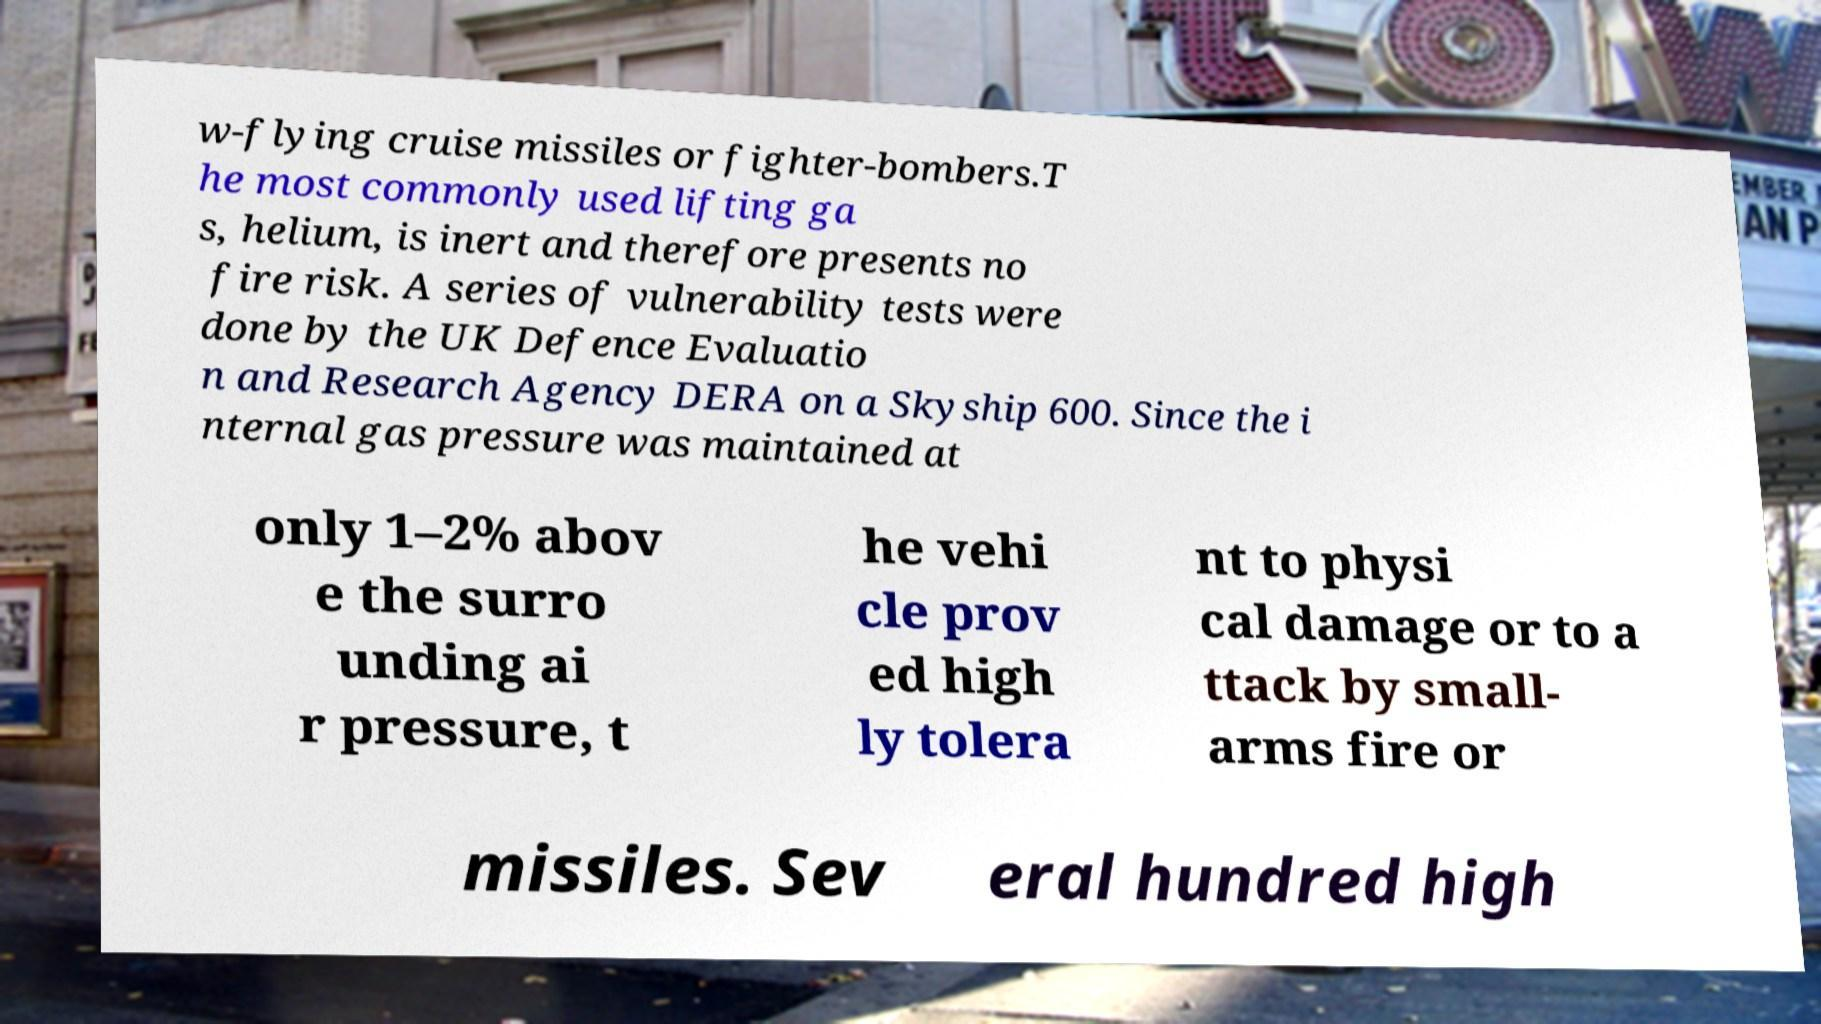Could you assist in decoding the text presented in this image and type it out clearly? w-flying cruise missiles or fighter-bombers.T he most commonly used lifting ga s, helium, is inert and therefore presents no fire risk. A series of vulnerability tests were done by the UK Defence Evaluatio n and Research Agency DERA on a Skyship 600. Since the i nternal gas pressure was maintained at only 1–2% abov e the surro unding ai r pressure, t he vehi cle prov ed high ly tolera nt to physi cal damage or to a ttack by small- arms fire or missiles. Sev eral hundred high 